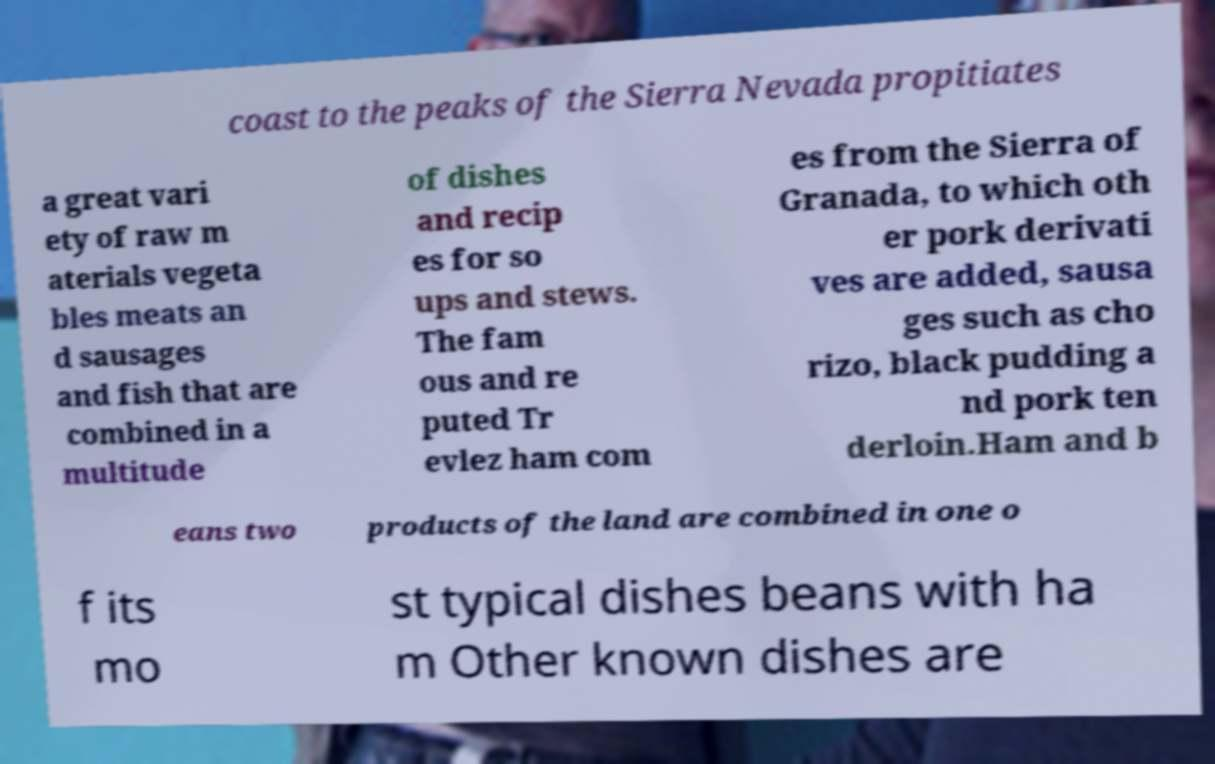Can you accurately transcribe the text from the provided image for me? coast to the peaks of the Sierra Nevada propitiates a great vari ety of raw m aterials vegeta bles meats an d sausages and fish that are combined in a multitude of dishes and recip es for so ups and stews. The fam ous and re puted Tr evlez ham com es from the Sierra of Granada, to which oth er pork derivati ves are added, sausa ges such as cho rizo, black pudding a nd pork ten derloin.Ham and b eans two products of the land are combined in one o f its mo st typical dishes beans with ha m Other known dishes are 